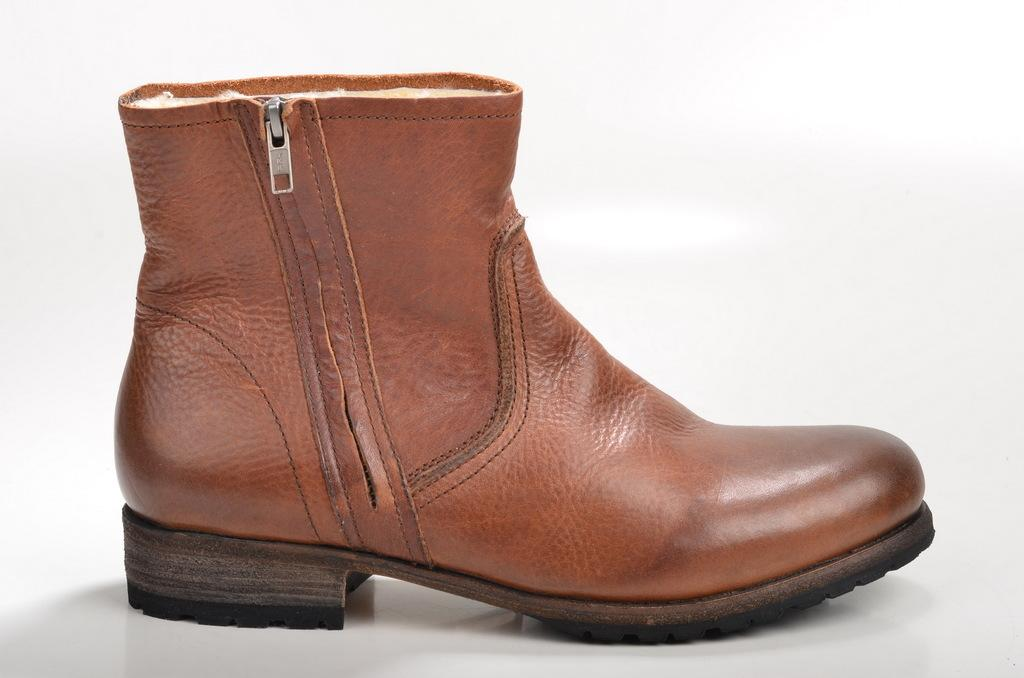What object is present in the image? There is a shoe in the image. How many ants are crawling on the shoe in the image? There are no ants present in the image; it only features a shoe. 